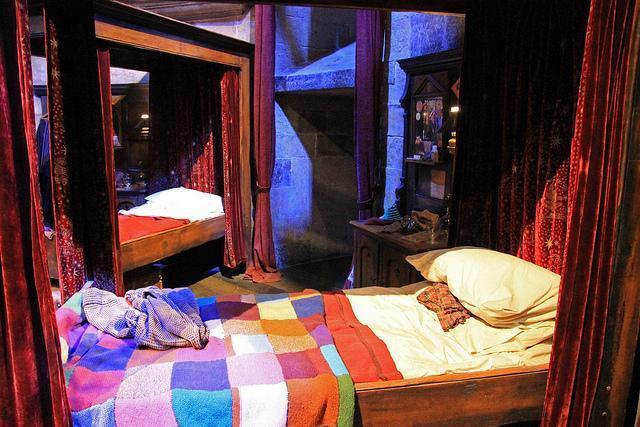How many beds are there?
Give a very brief answer. 2. 